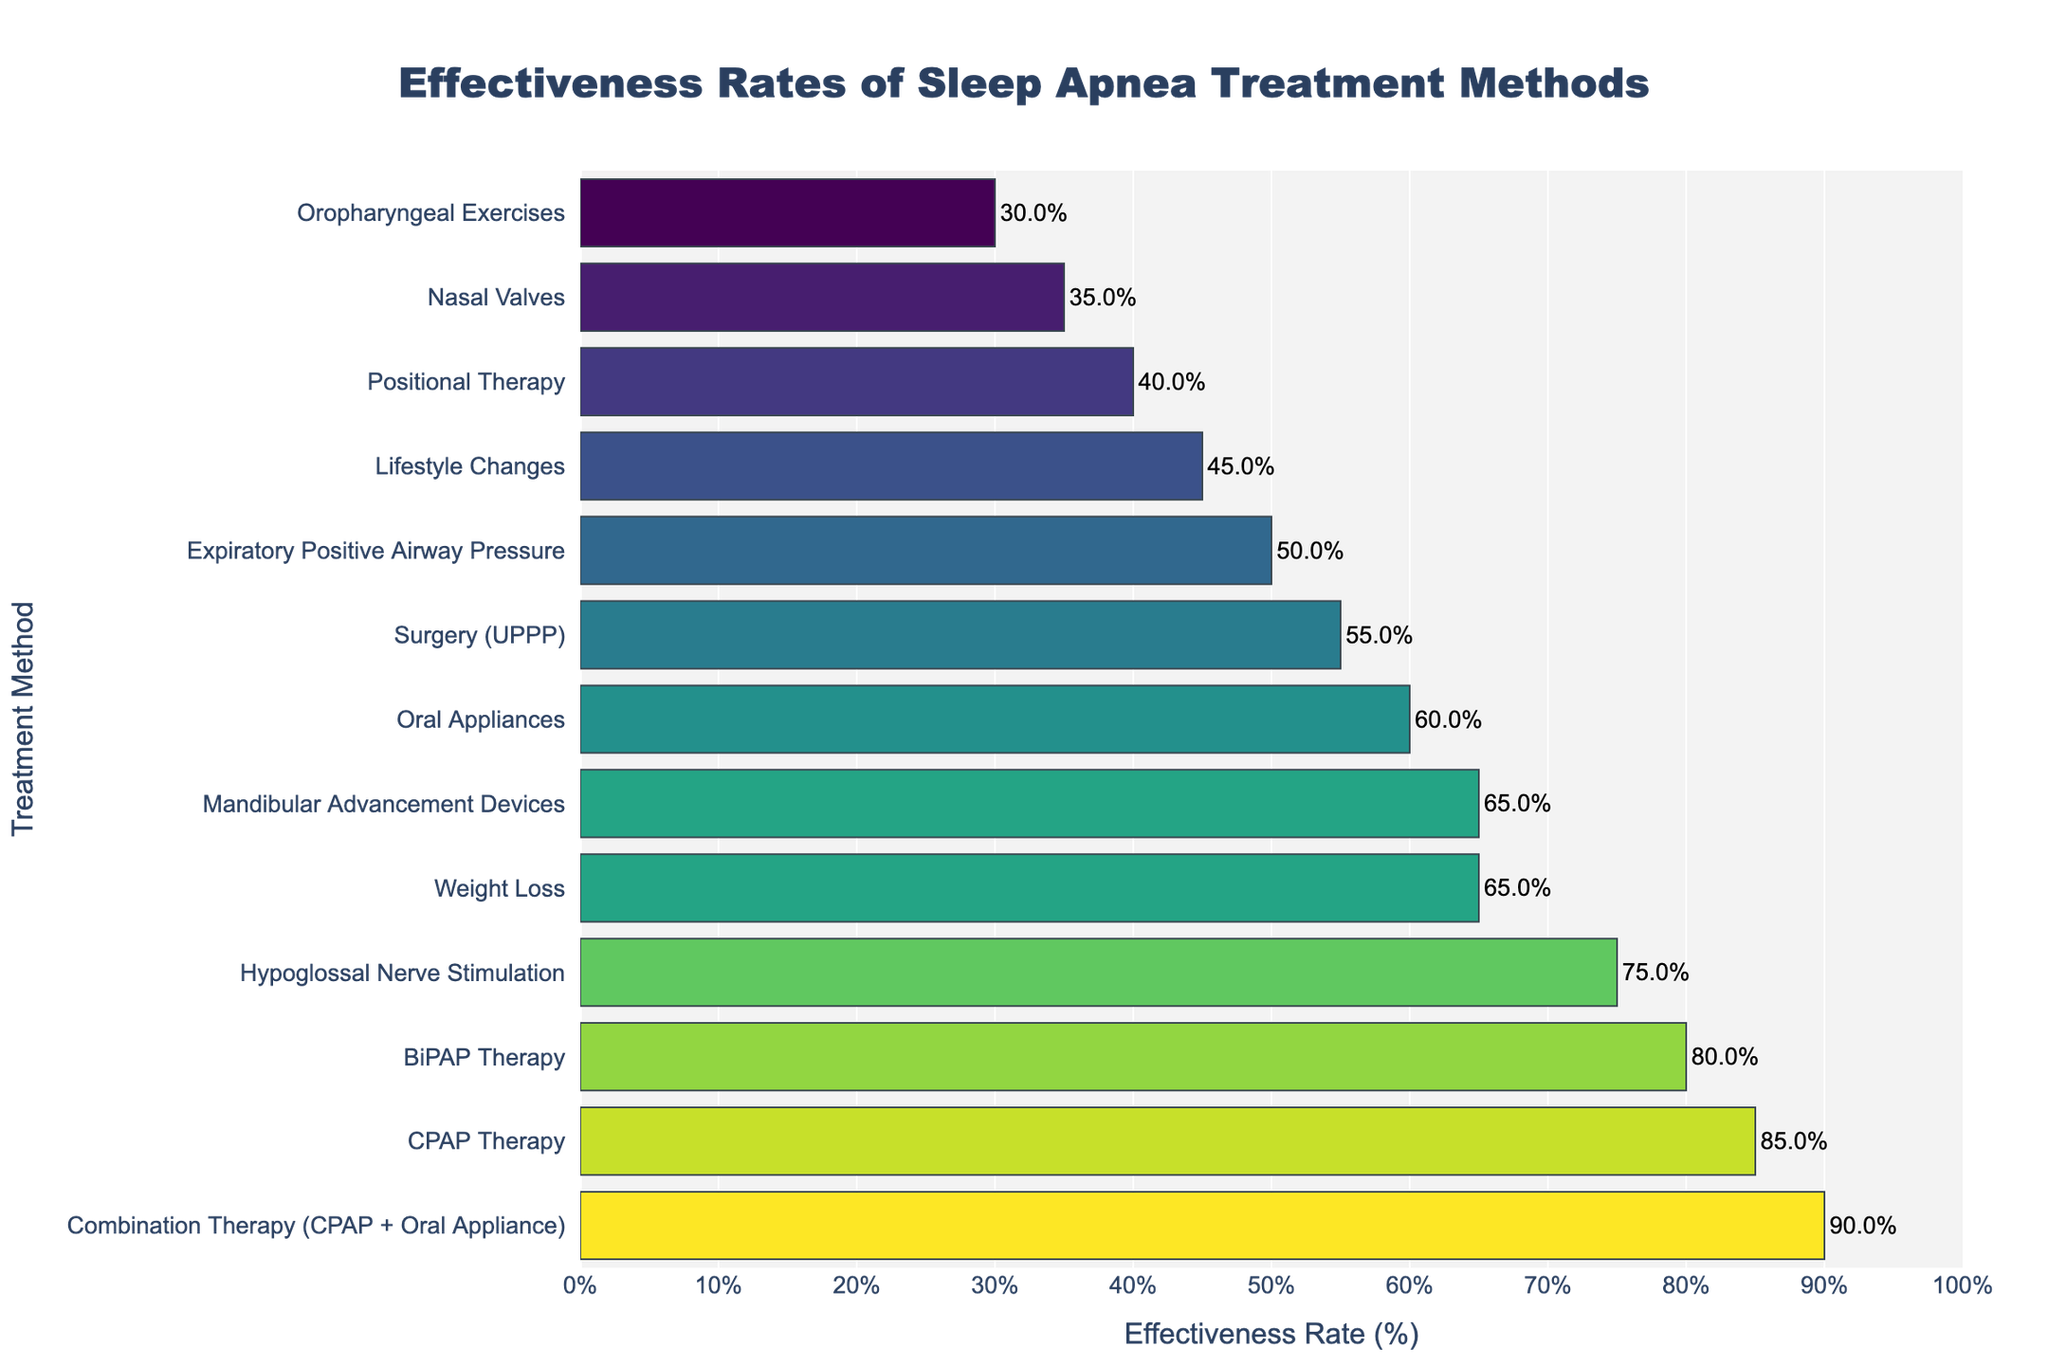What's the most effective treatment method for sleep apnea according to the chart? The chart shows that Combination Therapy (CPAP + Oral Appliance) has the highest effectiveness rate at 90%.
Answer: Combination Therapy (CPAP + Oral Appliance) Which treatment method is the least effective? The chart indicates that Oropharyngeal Exercises have the lowest effectiveness rate at 30%.
Answer: Oropharyngeal Exercises How much more effective is CPAP Therapy compared to Oral Appliances? CPAP Therapy has an effectiveness rate of 85%, while Oral Appliances have an effectiveness rate of 60%. The difference is 85% - 60% = 25%.
Answer: 25% What is the average effectiveness rate of the three least effective treatment methods? The three least effective treatments are Oropharyngeal Exercises (30%), Nasal Valves (35%), and Positional Therapy (40%). The average is (30 + 35 + 40) / 3 = 35%.
Answer: 35% Which treatment methods have an effectiveness rate of 65%? According to the chart, Weight Loss and Mandibular Advancement Devices both have an effectiveness rate of 65%.
Answer: Weight Loss, Mandibular Advancement Devices Which treatment method has a higher effectiveness rate: Surgery (UPPP) or Hypoglossal Nerve Stimulation? The chart shows that Hypoglossal Nerve Stimulation has an effectiveness rate of 75%, whereas Surgery (UPPP) has an effectiveness rate of 55%. Thus, Hypoglossal Nerve Stimulation is higher.
Answer: Hypoglossal Nerve Stimulation What is the combined effectiveness rate of Weight Loss and Lifestyle Changes? Weight Loss has an effectiveness rate of 65%, and Lifestyle Changes have an effectiveness rate of 45%. The combined rate is 65% + 45% = 110%.
Answer: 110% How does the effectiveness of BiPAP Therapy compare to CPAP Therapy visually? Visually, the bar representing CPAP Therapy is longer than the bar for BiPAP Therapy. CPAP Therapy has an effectiveness rate of 85% while BiPAP Therapy's rate is 80%. The difference in length represents a 5% difference in effectiveness.
Answer: BiPAP Therapy is less effective Are there any treatment methods with effectiveness rates within the range of 40% to 50%? The chart shows that Positional Therapy (40%), Expiratory Positive Airway Pressure (50%), and Lifestyle Changes (45%) fall within the 40%-50% range.
Answer: Positional Therapy, Expiratory Positive Airway Pressure, Lifestyle Changes 